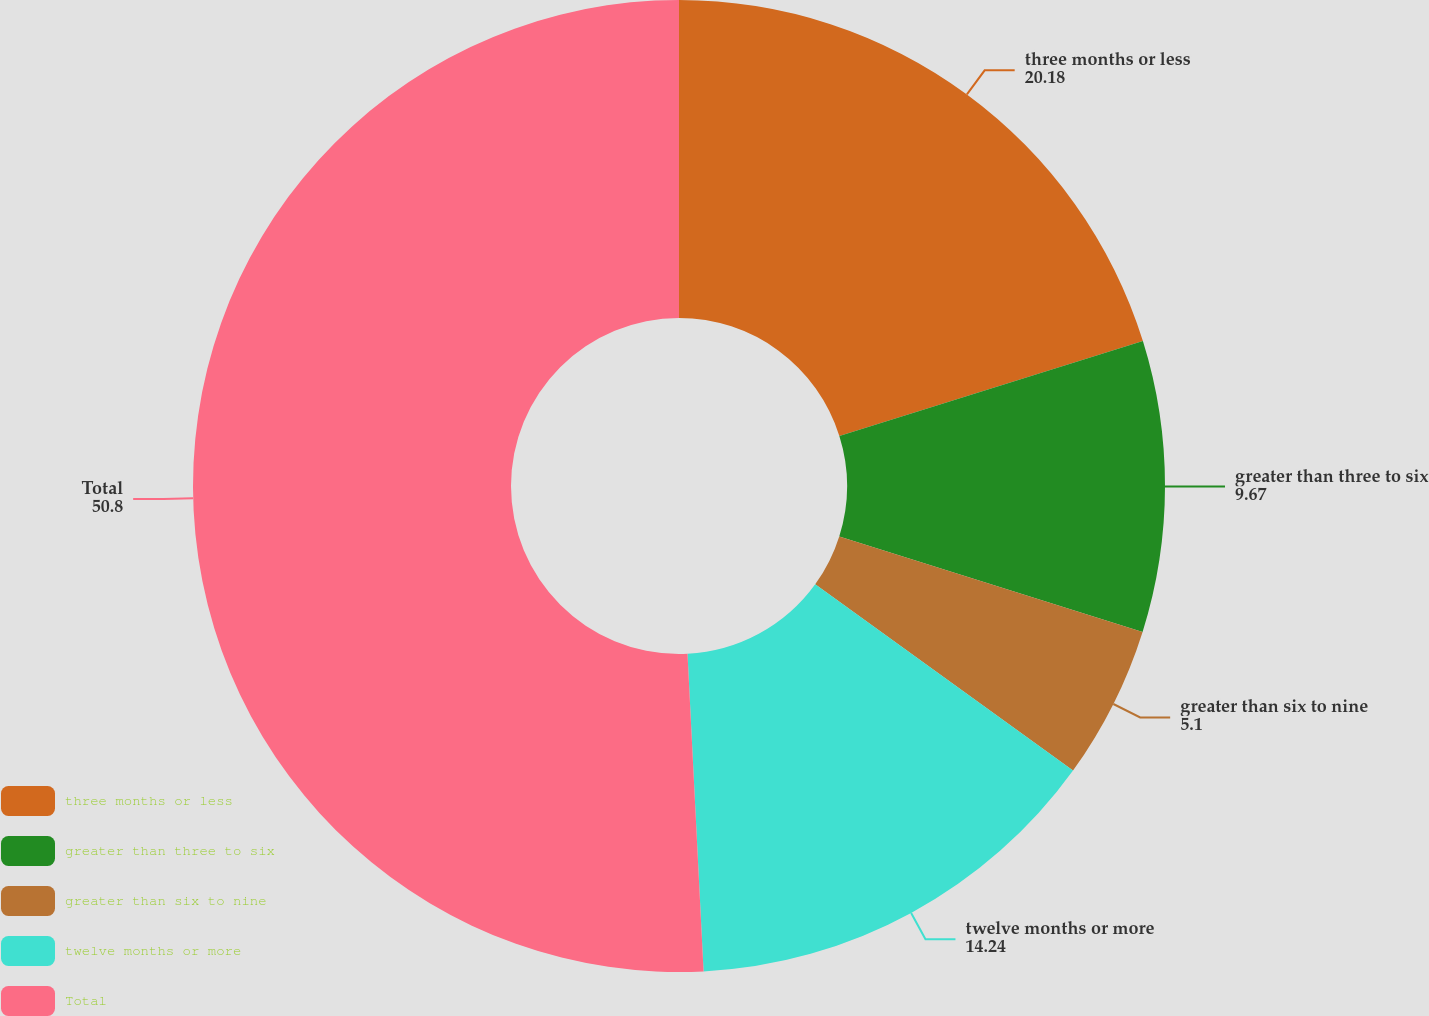<chart> <loc_0><loc_0><loc_500><loc_500><pie_chart><fcel>three months or less<fcel>greater than three to six<fcel>greater than six to nine<fcel>twelve months or more<fcel>Total<nl><fcel>20.18%<fcel>9.67%<fcel>5.1%<fcel>14.24%<fcel>50.8%<nl></chart> 